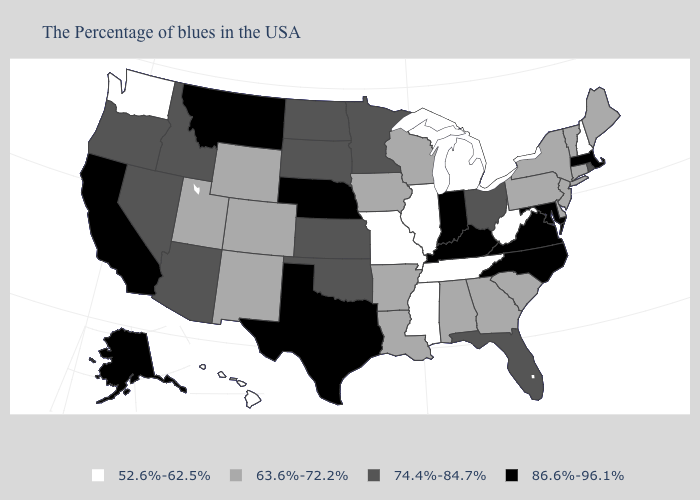Among the states that border Vermont , which have the lowest value?
Give a very brief answer. New Hampshire. Name the states that have a value in the range 63.6%-72.2%?
Answer briefly. Maine, Vermont, Connecticut, New York, New Jersey, Delaware, Pennsylvania, South Carolina, Georgia, Alabama, Wisconsin, Louisiana, Arkansas, Iowa, Wyoming, Colorado, New Mexico, Utah. Name the states that have a value in the range 74.4%-84.7%?
Answer briefly. Rhode Island, Ohio, Florida, Minnesota, Kansas, Oklahoma, South Dakota, North Dakota, Arizona, Idaho, Nevada, Oregon. Does Tennessee have the same value as Michigan?
Write a very short answer. Yes. How many symbols are there in the legend?
Give a very brief answer. 4. Name the states that have a value in the range 74.4%-84.7%?
Concise answer only. Rhode Island, Ohio, Florida, Minnesota, Kansas, Oklahoma, South Dakota, North Dakota, Arizona, Idaho, Nevada, Oregon. Does the first symbol in the legend represent the smallest category?
Quick response, please. Yes. Does the map have missing data?
Be succinct. No. Name the states that have a value in the range 52.6%-62.5%?
Give a very brief answer. New Hampshire, West Virginia, Michigan, Tennessee, Illinois, Mississippi, Missouri, Washington, Hawaii. Among the states that border Montana , which have the highest value?
Concise answer only. South Dakota, North Dakota, Idaho. Name the states that have a value in the range 63.6%-72.2%?
Keep it brief. Maine, Vermont, Connecticut, New York, New Jersey, Delaware, Pennsylvania, South Carolina, Georgia, Alabama, Wisconsin, Louisiana, Arkansas, Iowa, Wyoming, Colorado, New Mexico, Utah. Does the first symbol in the legend represent the smallest category?
Short answer required. Yes. Name the states that have a value in the range 63.6%-72.2%?
Quick response, please. Maine, Vermont, Connecticut, New York, New Jersey, Delaware, Pennsylvania, South Carolina, Georgia, Alabama, Wisconsin, Louisiana, Arkansas, Iowa, Wyoming, Colorado, New Mexico, Utah. What is the value of Mississippi?
Keep it brief. 52.6%-62.5%. Which states have the lowest value in the USA?
Give a very brief answer. New Hampshire, West Virginia, Michigan, Tennessee, Illinois, Mississippi, Missouri, Washington, Hawaii. 